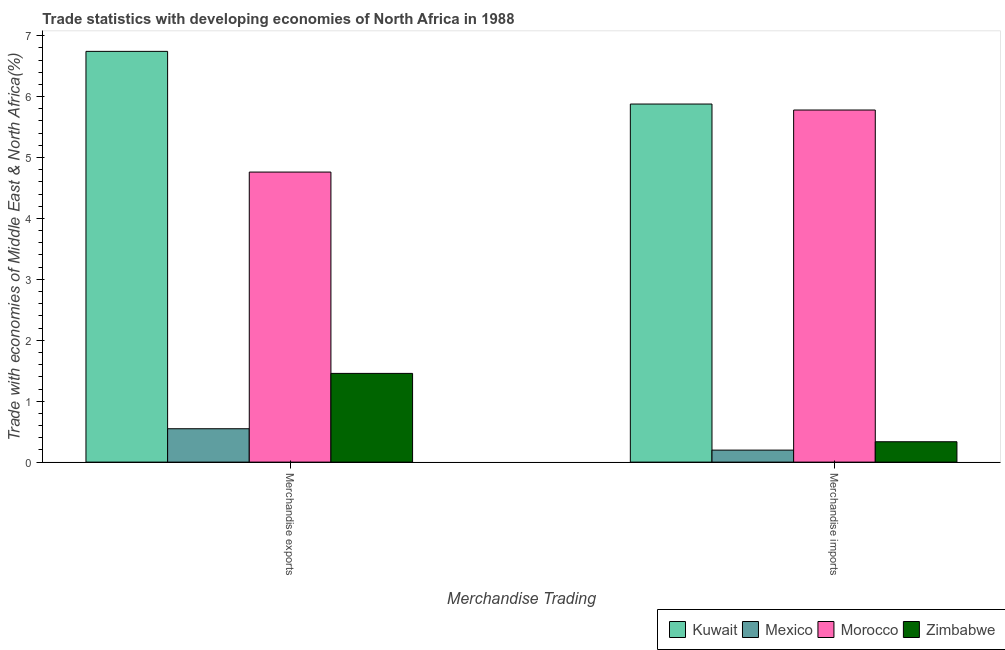How many different coloured bars are there?
Provide a succinct answer. 4. How many groups of bars are there?
Your response must be concise. 2. Are the number of bars per tick equal to the number of legend labels?
Offer a very short reply. Yes. Are the number of bars on each tick of the X-axis equal?
Provide a succinct answer. Yes. What is the label of the 2nd group of bars from the left?
Ensure brevity in your answer.  Merchandise imports. What is the merchandise exports in Kuwait?
Provide a succinct answer. 6.74. Across all countries, what is the maximum merchandise imports?
Your answer should be very brief. 5.88. Across all countries, what is the minimum merchandise imports?
Give a very brief answer. 0.2. In which country was the merchandise exports maximum?
Keep it short and to the point. Kuwait. In which country was the merchandise exports minimum?
Your answer should be very brief. Mexico. What is the total merchandise imports in the graph?
Offer a very short reply. 12.19. What is the difference between the merchandise imports in Morocco and that in Zimbabwe?
Provide a short and direct response. 5.45. What is the difference between the merchandise exports in Morocco and the merchandise imports in Zimbabwe?
Provide a short and direct response. 4.43. What is the average merchandise exports per country?
Give a very brief answer. 3.38. What is the difference between the merchandise exports and merchandise imports in Zimbabwe?
Your answer should be compact. 1.12. What is the ratio of the merchandise imports in Morocco to that in Zimbabwe?
Provide a succinct answer. 17.28. In how many countries, is the merchandise imports greater than the average merchandise imports taken over all countries?
Ensure brevity in your answer.  2. What does the 3rd bar from the left in Merchandise imports represents?
Your response must be concise. Morocco. What does the 4th bar from the right in Merchandise exports represents?
Keep it short and to the point. Kuwait. How many bars are there?
Provide a short and direct response. 8. How many countries are there in the graph?
Keep it short and to the point. 4. Are the values on the major ticks of Y-axis written in scientific E-notation?
Your response must be concise. No. Does the graph contain grids?
Your answer should be very brief. No. Where does the legend appear in the graph?
Ensure brevity in your answer.  Bottom right. How many legend labels are there?
Provide a short and direct response. 4. How are the legend labels stacked?
Provide a succinct answer. Horizontal. What is the title of the graph?
Give a very brief answer. Trade statistics with developing economies of North Africa in 1988. Does "Nigeria" appear as one of the legend labels in the graph?
Make the answer very short. No. What is the label or title of the X-axis?
Provide a succinct answer. Merchandise Trading. What is the label or title of the Y-axis?
Provide a short and direct response. Trade with economies of Middle East & North Africa(%). What is the Trade with economies of Middle East & North Africa(%) in Kuwait in Merchandise exports?
Your answer should be very brief. 6.74. What is the Trade with economies of Middle East & North Africa(%) in Mexico in Merchandise exports?
Ensure brevity in your answer.  0.55. What is the Trade with economies of Middle East & North Africa(%) of Morocco in Merchandise exports?
Your answer should be compact. 4.76. What is the Trade with economies of Middle East & North Africa(%) in Zimbabwe in Merchandise exports?
Your answer should be very brief. 1.46. What is the Trade with economies of Middle East & North Africa(%) in Kuwait in Merchandise imports?
Provide a short and direct response. 5.88. What is the Trade with economies of Middle East & North Africa(%) of Mexico in Merchandise imports?
Your response must be concise. 0.2. What is the Trade with economies of Middle East & North Africa(%) of Morocco in Merchandise imports?
Your answer should be very brief. 5.78. What is the Trade with economies of Middle East & North Africa(%) in Zimbabwe in Merchandise imports?
Your answer should be very brief. 0.33. Across all Merchandise Trading, what is the maximum Trade with economies of Middle East & North Africa(%) in Kuwait?
Offer a very short reply. 6.74. Across all Merchandise Trading, what is the maximum Trade with economies of Middle East & North Africa(%) of Mexico?
Your answer should be compact. 0.55. Across all Merchandise Trading, what is the maximum Trade with economies of Middle East & North Africa(%) of Morocco?
Your answer should be very brief. 5.78. Across all Merchandise Trading, what is the maximum Trade with economies of Middle East & North Africa(%) of Zimbabwe?
Your answer should be compact. 1.46. Across all Merchandise Trading, what is the minimum Trade with economies of Middle East & North Africa(%) in Kuwait?
Provide a succinct answer. 5.88. Across all Merchandise Trading, what is the minimum Trade with economies of Middle East & North Africa(%) of Mexico?
Provide a succinct answer. 0.2. Across all Merchandise Trading, what is the minimum Trade with economies of Middle East & North Africa(%) in Morocco?
Your answer should be very brief. 4.76. Across all Merchandise Trading, what is the minimum Trade with economies of Middle East & North Africa(%) in Zimbabwe?
Your answer should be very brief. 0.33. What is the total Trade with economies of Middle East & North Africa(%) in Kuwait in the graph?
Keep it short and to the point. 12.62. What is the total Trade with economies of Middle East & North Africa(%) in Mexico in the graph?
Offer a very short reply. 0.75. What is the total Trade with economies of Middle East & North Africa(%) of Morocco in the graph?
Offer a very short reply. 10.54. What is the total Trade with economies of Middle East & North Africa(%) in Zimbabwe in the graph?
Make the answer very short. 1.79. What is the difference between the Trade with economies of Middle East & North Africa(%) of Kuwait in Merchandise exports and that in Merchandise imports?
Ensure brevity in your answer.  0.86. What is the difference between the Trade with economies of Middle East & North Africa(%) in Mexico in Merchandise exports and that in Merchandise imports?
Make the answer very short. 0.35. What is the difference between the Trade with economies of Middle East & North Africa(%) in Morocco in Merchandise exports and that in Merchandise imports?
Your answer should be compact. -1.02. What is the difference between the Trade with economies of Middle East & North Africa(%) of Zimbabwe in Merchandise exports and that in Merchandise imports?
Offer a very short reply. 1.12. What is the difference between the Trade with economies of Middle East & North Africa(%) in Kuwait in Merchandise exports and the Trade with economies of Middle East & North Africa(%) in Mexico in Merchandise imports?
Provide a short and direct response. 6.55. What is the difference between the Trade with economies of Middle East & North Africa(%) of Kuwait in Merchandise exports and the Trade with economies of Middle East & North Africa(%) of Morocco in Merchandise imports?
Make the answer very short. 0.96. What is the difference between the Trade with economies of Middle East & North Africa(%) in Kuwait in Merchandise exports and the Trade with economies of Middle East & North Africa(%) in Zimbabwe in Merchandise imports?
Offer a very short reply. 6.41. What is the difference between the Trade with economies of Middle East & North Africa(%) of Mexico in Merchandise exports and the Trade with economies of Middle East & North Africa(%) of Morocco in Merchandise imports?
Offer a very short reply. -5.23. What is the difference between the Trade with economies of Middle East & North Africa(%) in Mexico in Merchandise exports and the Trade with economies of Middle East & North Africa(%) in Zimbabwe in Merchandise imports?
Your answer should be very brief. 0.21. What is the difference between the Trade with economies of Middle East & North Africa(%) in Morocco in Merchandise exports and the Trade with economies of Middle East & North Africa(%) in Zimbabwe in Merchandise imports?
Your response must be concise. 4.43. What is the average Trade with economies of Middle East & North Africa(%) of Kuwait per Merchandise Trading?
Ensure brevity in your answer.  6.31. What is the average Trade with economies of Middle East & North Africa(%) of Mexico per Merchandise Trading?
Your answer should be compact. 0.37. What is the average Trade with economies of Middle East & North Africa(%) of Morocco per Merchandise Trading?
Keep it short and to the point. 5.27. What is the average Trade with economies of Middle East & North Africa(%) of Zimbabwe per Merchandise Trading?
Your answer should be compact. 0.9. What is the difference between the Trade with economies of Middle East & North Africa(%) of Kuwait and Trade with economies of Middle East & North Africa(%) of Mexico in Merchandise exports?
Keep it short and to the point. 6.19. What is the difference between the Trade with economies of Middle East & North Africa(%) in Kuwait and Trade with economies of Middle East & North Africa(%) in Morocco in Merchandise exports?
Make the answer very short. 1.98. What is the difference between the Trade with economies of Middle East & North Africa(%) in Kuwait and Trade with economies of Middle East & North Africa(%) in Zimbabwe in Merchandise exports?
Provide a succinct answer. 5.29. What is the difference between the Trade with economies of Middle East & North Africa(%) of Mexico and Trade with economies of Middle East & North Africa(%) of Morocco in Merchandise exports?
Provide a succinct answer. -4.21. What is the difference between the Trade with economies of Middle East & North Africa(%) of Mexico and Trade with economies of Middle East & North Africa(%) of Zimbabwe in Merchandise exports?
Keep it short and to the point. -0.91. What is the difference between the Trade with economies of Middle East & North Africa(%) in Morocco and Trade with economies of Middle East & North Africa(%) in Zimbabwe in Merchandise exports?
Offer a very short reply. 3.3. What is the difference between the Trade with economies of Middle East & North Africa(%) of Kuwait and Trade with economies of Middle East & North Africa(%) of Mexico in Merchandise imports?
Your response must be concise. 5.68. What is the difference between the Trade with economies of Middle East & North Africa(%) in Kuwait and Trade with economies of Middle East & North Africa(%) in Morocco in Merchandise imports?
Provide a succinct answer. 0.1. What is the difference between the Trade with economies of Middle East & North Africa(%) of Kuwait and Trade with economies of Middle East & North Africa(%) of Zimbabwe in Merchandise imports?
Provide a succinct answer. 5.54. What is the difference between the Trade with economies of Middle East & North Africa(%) in Mexico and Trade with economies of Middle East & North Africa(%) in Morocco in Merchandise imports?
Keep it short and to the point. -5.58. What is the difference between the Trade with economies of Middle East & North Africa(%) in Mexico and Trade with economies of Middle East & North Africa(%) in Zimbabwe in Merchandise imports?
Provide a succinct answer. -0.14. What is the difference between the Trade with economies of Middle East & North Africa(%) in Morocco and Trade with economies of Middle East & North Africa(%) in Zimbabwe in Merchandise imports?
Offer a very short reply. 5.45. What is the ratio of the Trade with economies of Middle East & North Africa(%) in Kuwait in Merchandise exports to that in Merchandise imports?
Your response must be concise. 1.15. What is the ratio of the Trade with economies of Middle East & North Africa(%) of Mexico in Merchandise exports to that in Merchandise imports?
Offer a very short reply. 2.78. What is the ratio of the Trade with economies of Middle East & North Africa(%) in Morocco in Merchandise exports to that in Merchandise imports?
Provide a short and direct response. 0.82. What is the ratio of the Trade with economies of Middle East & North Africa(%) of Zimbabwe in Merchandise exports to that in Merchandise imports?
Ensure brevity in your answer.  4.35. What is the difference between the highest and the second highest Trade with economies of Middle East & North Africa(%) in Kuwait?
Your response must be concise. 0.86. What is the difference between the highest and the second highest Trade with economies of Middle East & North Africa(%) in Mexico?
Provide a short and direct response. 0.35. What is the difference between the highest and the second highest Trade with economies of Middle East & North Africa(%) in Morocco?
Provide a short and direct response. 1.02. What is the difference between the highest and the second highest Trade with economies of Middle East & North Africa(%) in Zimbabwe?
Give a very brief answer. 1.12. What is the difference between the highest and the lowest Trade with economies of Middle East & North Africa(%) of Kuwait?
Offer a terse response. 0.86. What is the difference between the highest and the lowest Trade with economies of Middle East & North Africa(%) of Mexico?
Your response must be concise. 0.35. What is the difference between the highest and the lowest Trade with economies of Middle East & North Africa(%) in Morocco?
Make the answer very short. 1.02. What is the difference between the highest and the lowest Trade with economies of Middle East & North Africa(%) in Zimbabwe?
Offer a terse response. 1.12. 